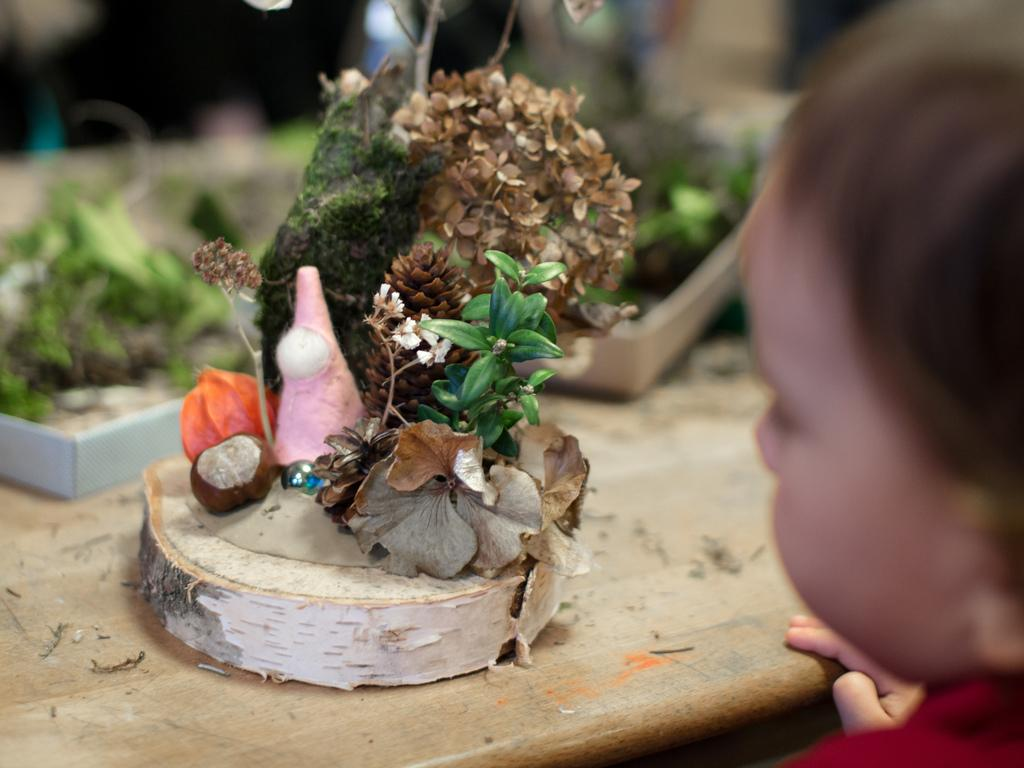What is the main subject of the image? There is a child in the image. What object can be seen in the image besides the child? There is a table in the image. What is placed on the table? There are plants on the table. Can you describe the background of the image? The background of the image is blurred. What type of fight is happening in the background of the image? There is no fight present in the image; the background is blurred. What direction is the sun shining from in the image? The image does not show the sun, so it cannot be determined from which direction the sun is shining. 